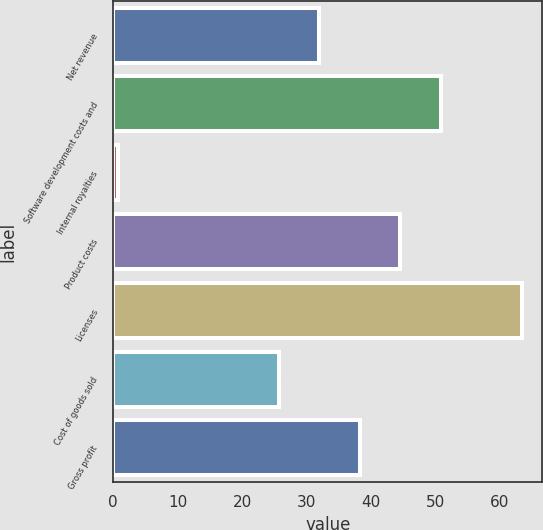<chart> <loc_0><loc_0><loc_500><loc_500><bar_chart><fcel>Net revenue<fcel>Software development costs and<fcel>Internal royalties<fcel>Product costs<fcel>Licenses<fcel>Cost of goods sold<fcel>Gross profit<nl><fcel>31.97<fcel>50.78<fcel>0.7<fcel>44.51<fcel>63.4<fcel>25.7<fcel>38.24<nl></chart> 